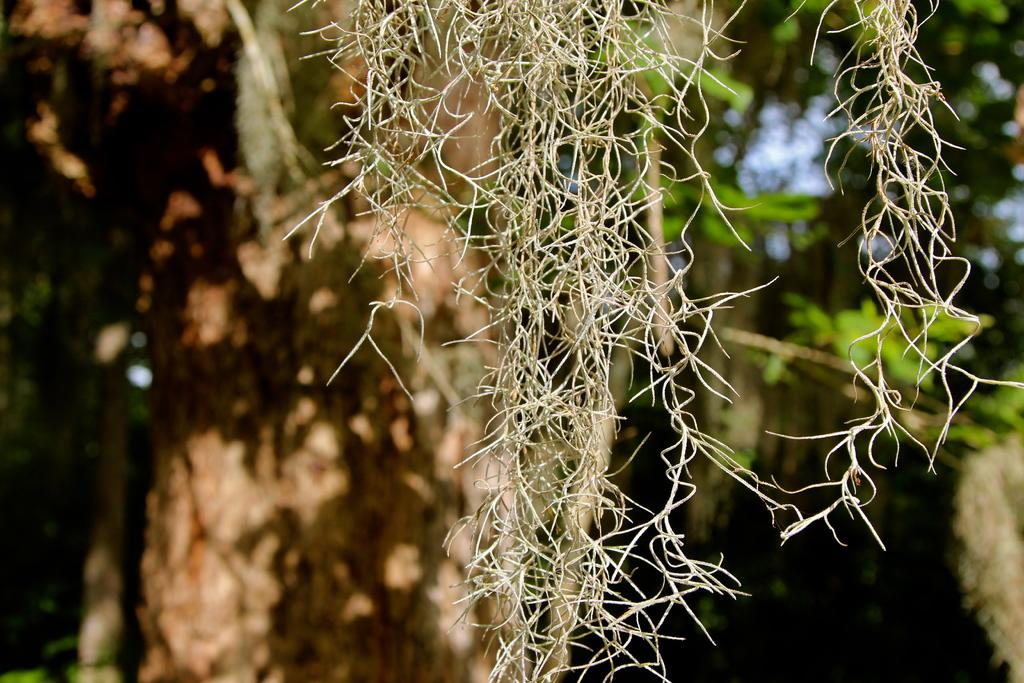What type of plant is in the image? There is a dried plant in the image. Can you describe the background of the image? The background is blurry. What can be seen in the background of the image? Greenery is visible in the background. What organization is responsible for delivering the parcel in the image? There is no parcel present in the image, so it is not possible to determine which organization might be responsible for delivering it. 